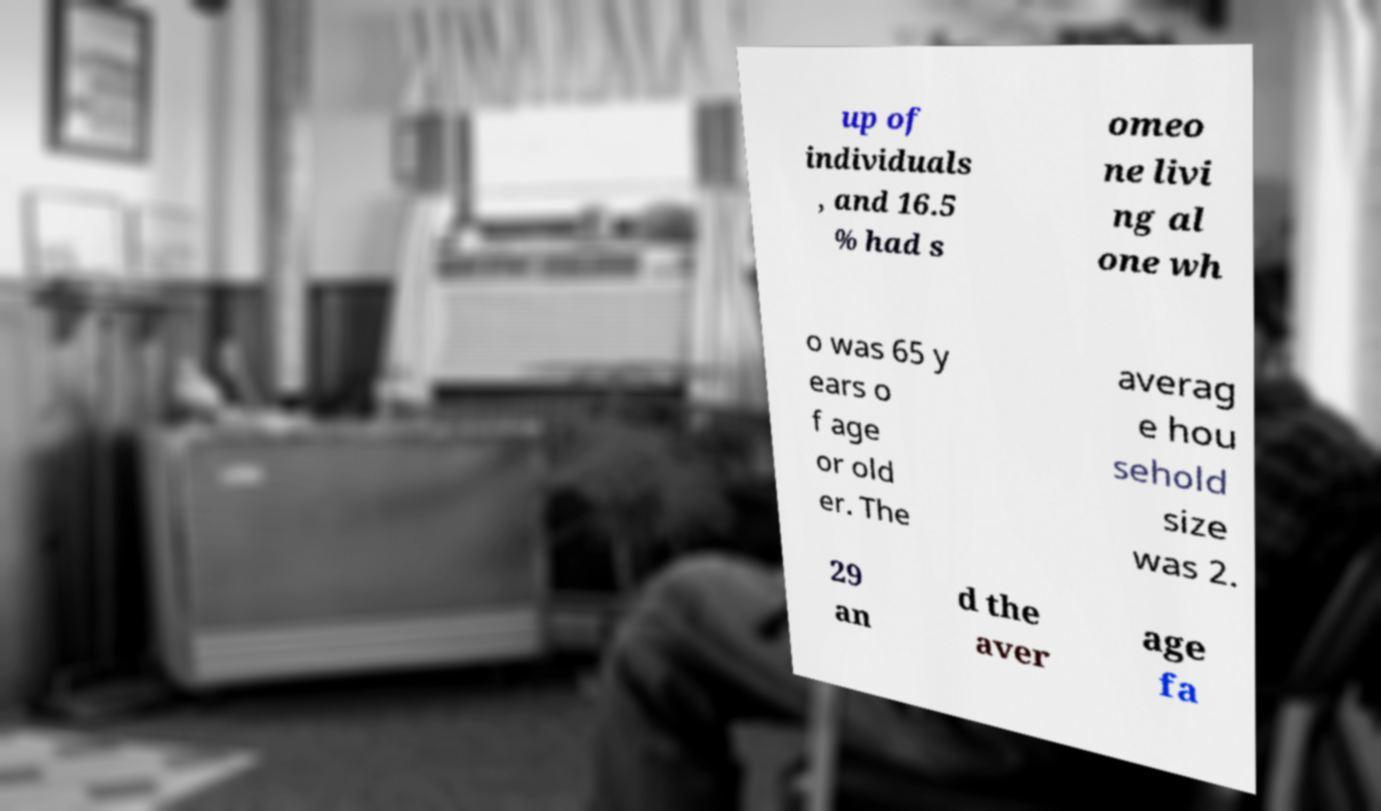There's text embedded in this image that I need extracted. Can you transcribe it verbatim? up of individuals , and 16.5 % had s omeo ne livi ng al one wh o was 65 y ears o f age or old er. The averag e hou sehold size was 2. 29 an d the aver age fa 